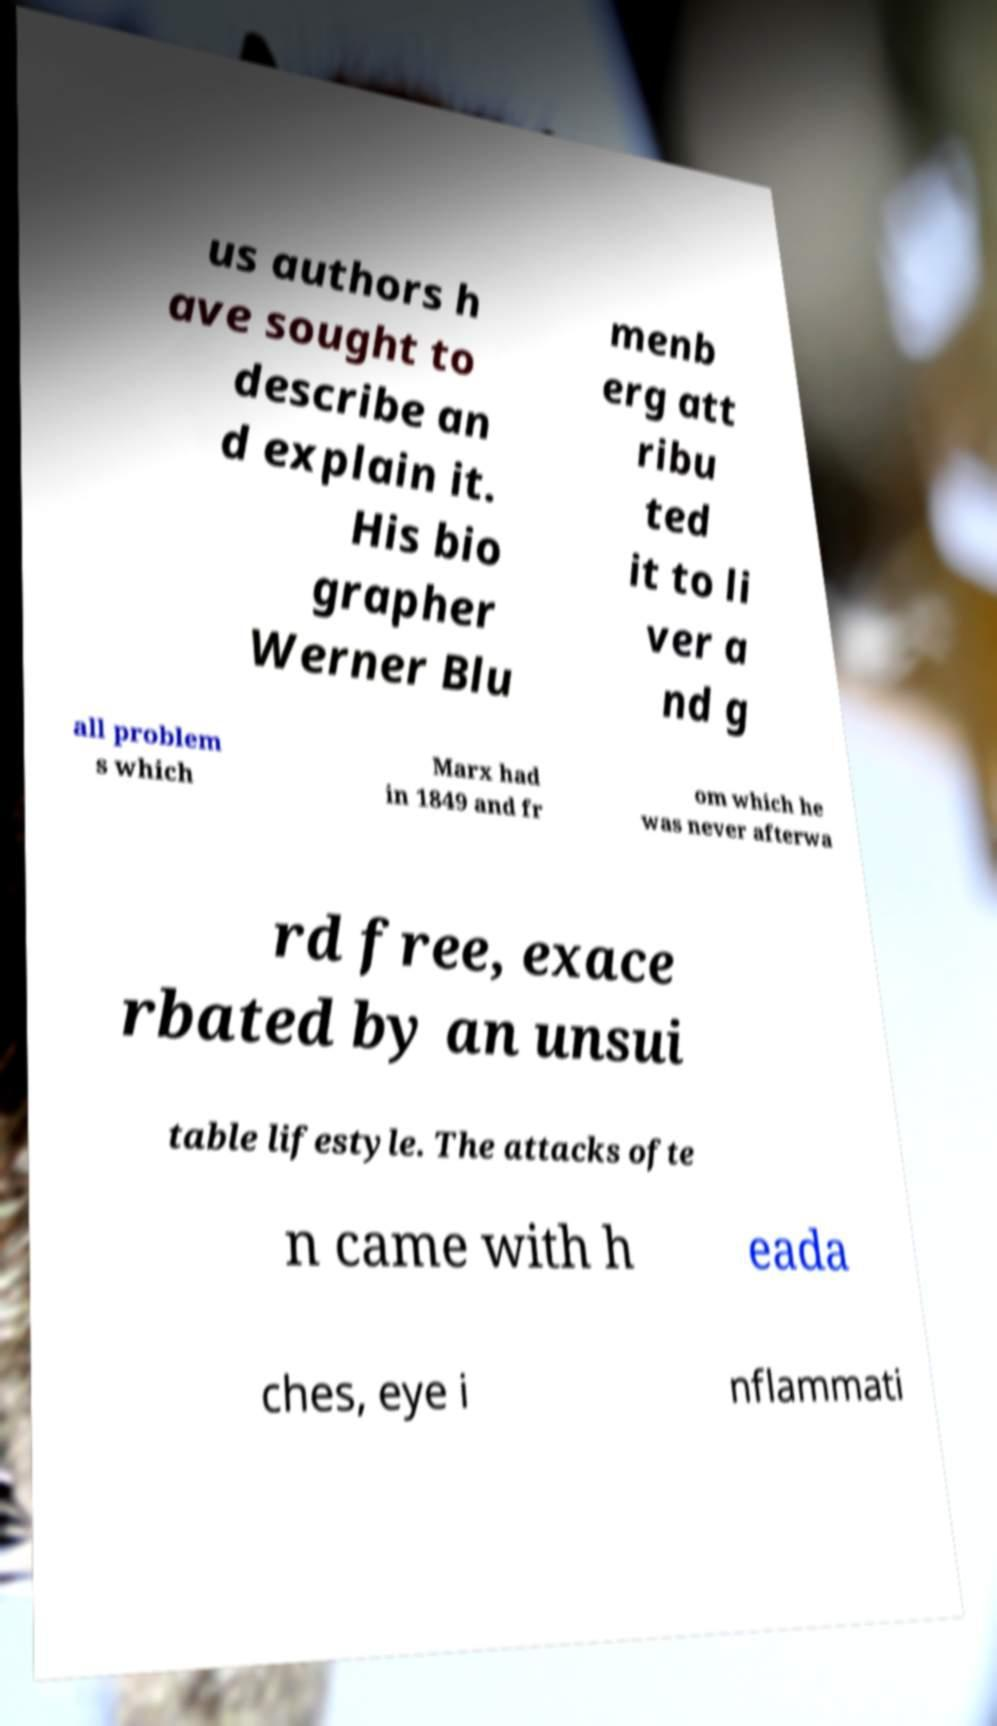Please identify and transcribe the text found in this image. us authors h ave sought to describe an d explain it. His bio grapher Werner Blu menb erg att ribu ted it to li ver a nd g all problem s which Marx had in 1849 and fr om which he was never afterwa rd free, exace rbated by an unsui table lifestyle. The attacks ofte n came with h eada ches, eye i nflammati 